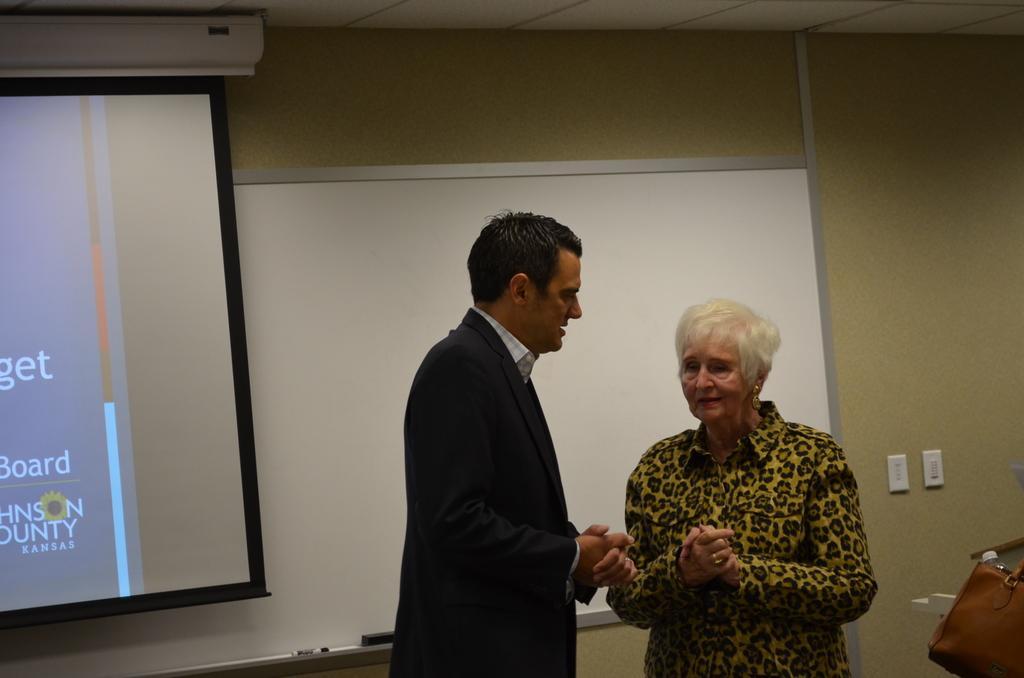Describe this image in one or two sentences. In this image I can see a man and a woman are standing. In the background I can see a white color board and switches on a wall. Here I can see a projector screen. 